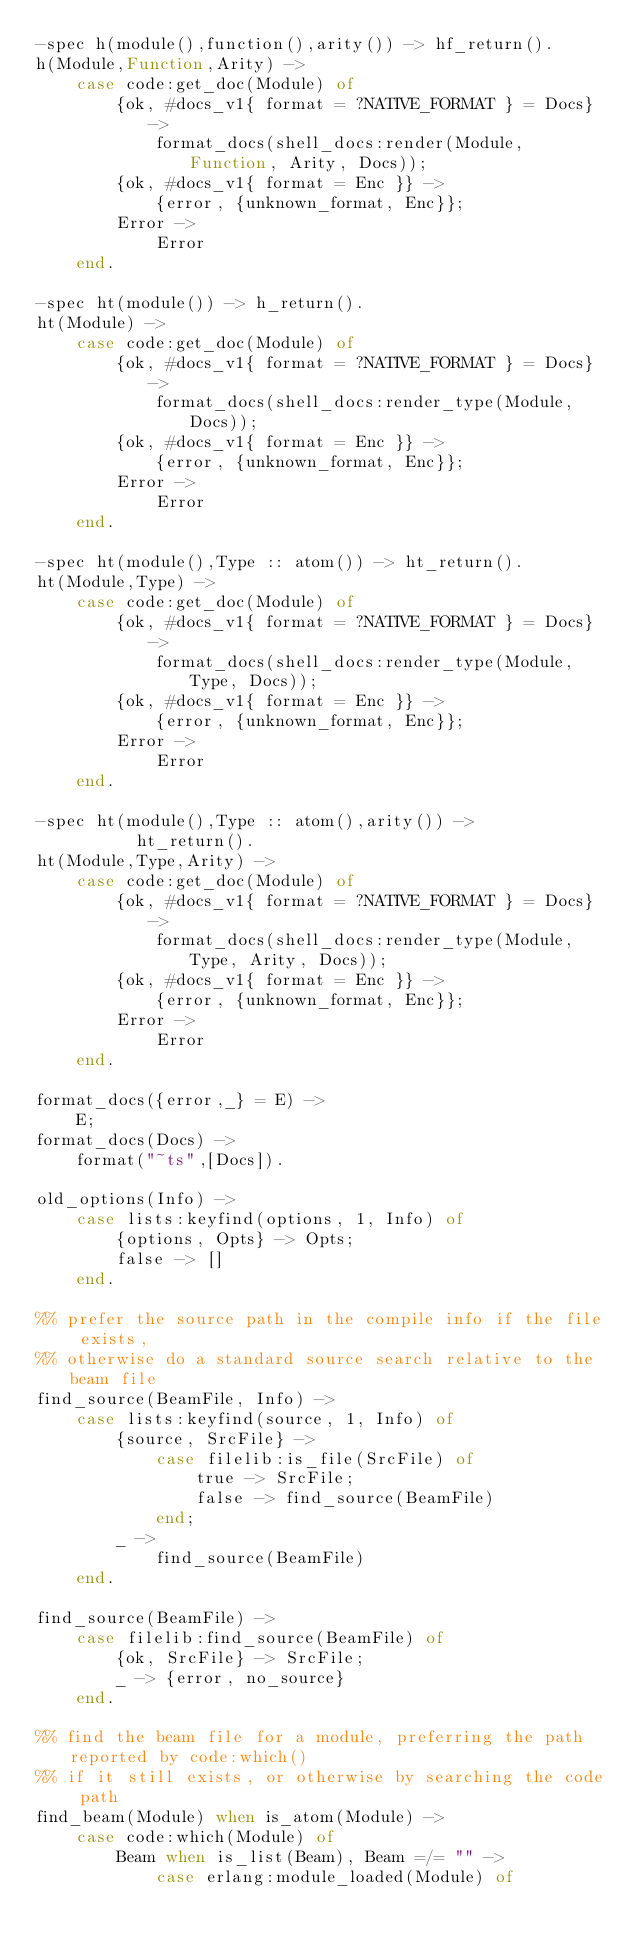Convert code to text. <code><loc_0><loc_0><loc_500><loc_500><_Erlang_>-spec h(module(),function(),arity()) -> hf_return().
h(Module,Function,Arity) ->
    case code:get_doc(Module) of
        {ok, #docs_v1{ format = ?NATIVE_FORMAT } = Docs} ->
            format_docs(shell_docs:render(Module, Function, Arity, Docs));
        {ok, #docs_v1{ format = Enc }} ->
            {error, {unknown_format, Enc}};
        Error ->
            Error
    end.

-spec ht(module()) -> h_return().
ht(Module) ->
    case code:get_doc(Module) of
        {ok, #docs_v1{ format = ?NATIVE_FORMAT } = Docs} ->
            format_docs(shell_docs:render_type(Module, Docs));
        {ok, #docs_v1{ format = Enc }} ->
            {error, {unknown_format, Enc}};
        Error ->
            Error
    end.

-spec ht(module(),Type :: atom()) -> ht_return().
ht(Module,Type) ->
    case code:get_doc(Module) of
        {ok, #docs_v1{ format = ?NATIVE_FORMAT } = Docs} ->
            format_docs(shell_docs:render_type(Module, Type, Docs));
        {ok, #docs_v1{ format = Enc }} ->
            {error, {unknown_format, Enc}};
        Error ->
            Error
    end.

-spec ht(module(),Type :: atom(),arity()) ->
          ht_return().
ht(Module,Type,Arity) ->
    case code:get_doc(Module) of
        {ok, #docs_v1{ format = ?NATIVE_FORMAT } = Docs} ->
            format_docs(shell_docs:render_type(Module, Type, Arity, Docs));
        {ok, #docs_v1{ format = Enc }} ->
            {error, {unknown_format, Enc}};
        Error ->
            Error
    end.

format_docs({error,_} = E) ->
    E;
format_docs(Docs) ->
    format("~ts",[Docs]).

old_options(Info) ->
    case lists:keyfind(options, 1, Info) of
        {options, Opts} -> Opts;
        false -> []
    end.

%% prefer the source path in the compile info if the file exists,
%% otherwise do a standard source search relative to the beam file
find_source(BeamFile, Info) ->
    case lists:keyfind(source, 1, Info) of
        {source, SrcFile} ->
            case filelib:is_file(SrcFile) of
                true -> SrcFile;
                false -> find_source(BeamFile)
            end;
        _ ->
            find_source(BeamFile)
    end.

find_source(BeamFile) ->
    case filelib:find_source(BeamFile) of
        {ok, SrcFile} -> SrcFile;
        _ -> {error, no_source}
    end.

%% find the beam file for a module, preferring the path reported by code:which()
%% if it still exists, or otherwise by searching the code path
find_beam(Module) when is_atom(Module) ->
    case code:which(Module) of
        Beam when is_list(Beam), Beam =/= "" ->
            case erlang:module_loaded(Module) of</code> 